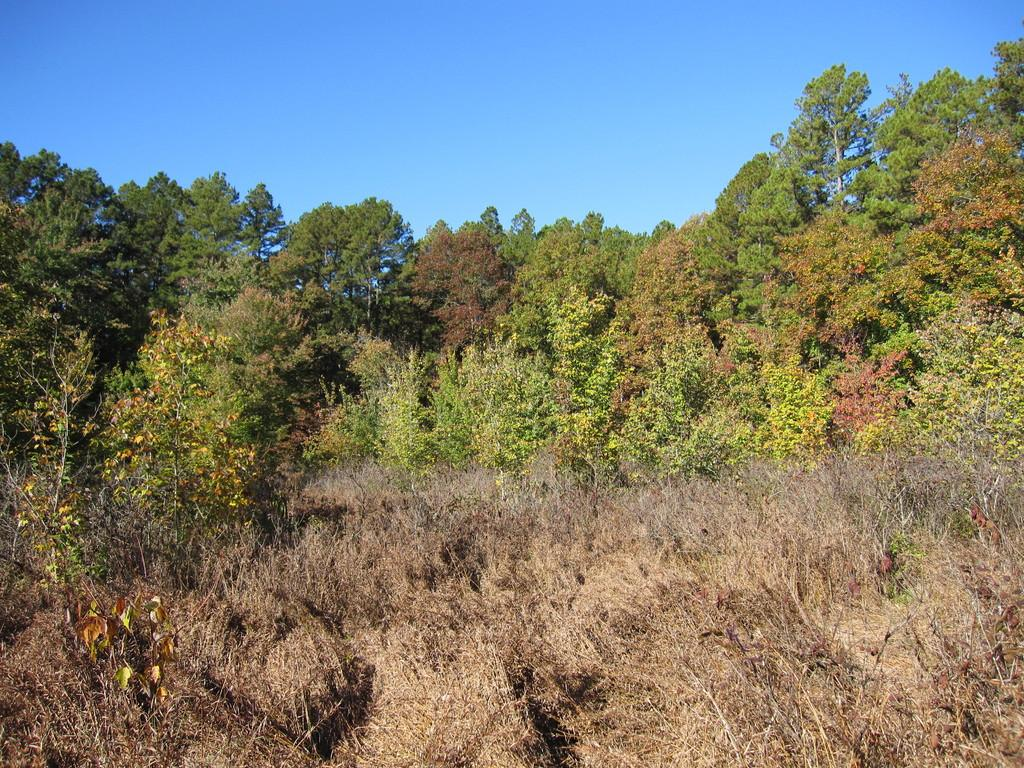What type of setting is depicted in the image? The image is an outside view. What can be seen at the bottom of the image? There are plants at the bottom of the image. What is located in the middle of the image? There are many trees in the middle of the image. What is visible at the top of the image? The sky is visible at the top of the image. Where is the room located in the image? There is no room present in the image; it is an outside view with plants, trees, and the sky. What type of screw can be seen holding the plants in the image? There are no screws visible in the image; it is an outdoor scene with plants and trees. 